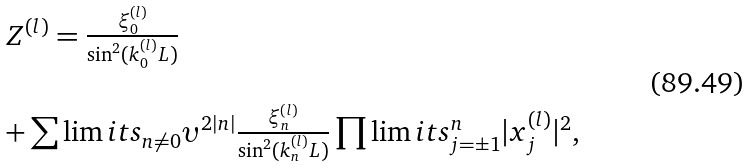<formula> <loc_0><loc_0><loc_500><loc_500>\begin{array} { l } Z ^ { ( l ) } = \frac { \xi _ { 0 } ^ { ( l ) } } { \sin ^ { 2 } ( k _ { 0 } ^ { ( l ) } L ) } \\ \ \\ + \sum \lim i t s _ { n \neq 0 } \upsilon ^ { 2 | n | } \frac { \xi _ { n } ^ { ( l ) } } { \sin ^ { 2 } ( k _ { n } ^ { ( l ) } L ) } \prod \lim i t s _ { j = \pm 1 } ^ { n } | x _ { j } ^ { ( l ) } | ^ { 2 } , \end{array}</formula> 